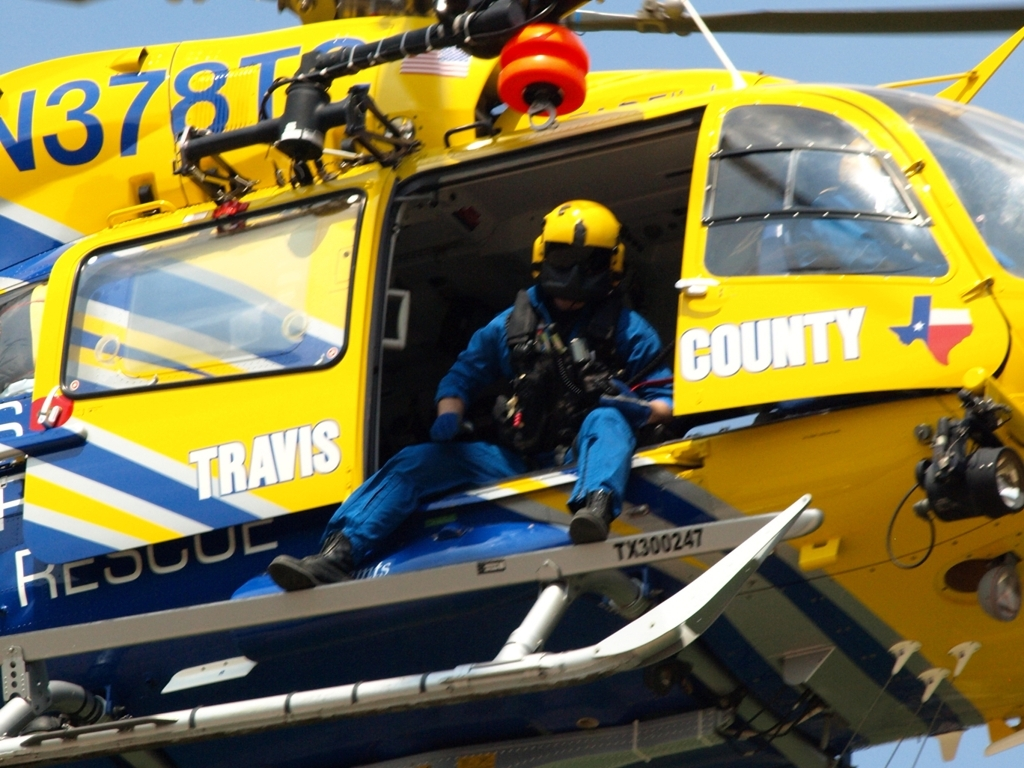Reflect on the role of such rescue operations in public safety. Rescue operations like the one shown play a vital role in public safety, offering rapid response capabilities in situations where time is of the essence, such as during natural disasters, accidents, or medical emergencies in remote areas. The dedicated teams and specialized equipment exemplify the commitment to saving lives and providing aid wherever needed, highlighting the importance and value of search and rescue services in any community. 